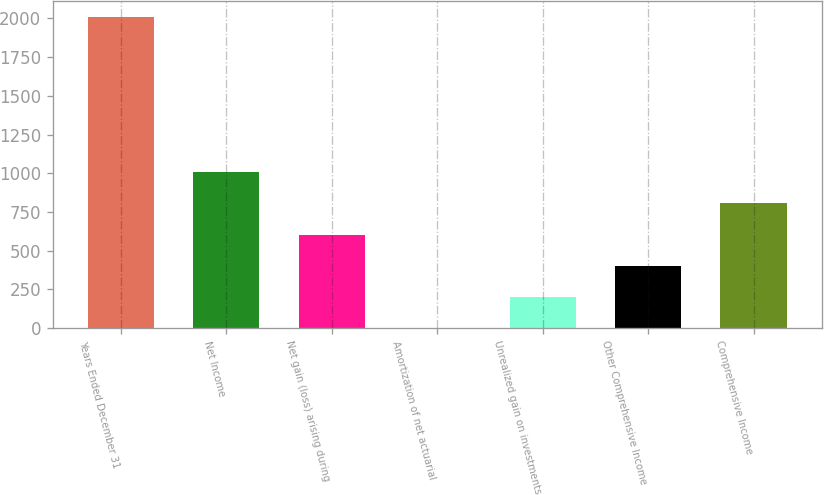Convert chart to OTSL. <chart><loc_0><loc_0><loc_500><loc_500><bar_chart><fcel>Years Ended December 31<fcel>Net Income<fcel>Net gain (loss) arising during<fcel>Amortization of net actuarial<fcel>Unrealized gain on investments<fcel>Other Comprehensive Income<fcel>Comprehensive Income<nl><fcel>2011<fcel>1006<fcel>604<fcel>1<fcel>202<fcel>403<fcel>805<nl></chart> 